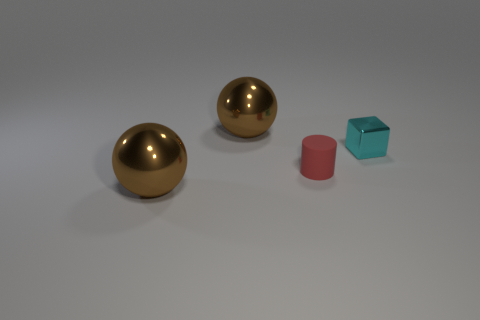Is there any other thing that has the same material as the small cylinder?
Offer a very short reply. No. There is a big metal thing that is behind the small shiny block; is its color the same as the rubber thing?
Offer a very short reply. No. What is the shape of the thing that is in front of the small cyan metal thing and left of the small matte object?
Provide a succinct answer. Sphere. What color is the thing in front of the tiny red rubber cylinder?
Your answer should be compact. Brown. Are there any other things that are the same color as the shiny cube?
Ensure brevity in your answer.  No. What number of spheres have the same material as the small cylinder?
Provide a succinct answer. 0. The matte thing is what color?
Ensure brevity in your answer.  Red. There is a thing that is behind the small cyan cube; does it have the same shape as the small red rubber thing?
Your answer should be very brief. No. How many objects are either big brown metal things that are behind the small cyan cube or tiny cubes?
Ensure brevity in your answer.  2. There is a cyan shiny thing that is the same size as the matte thing; what shape is it?
Ensure brevity in your answer.  Cube. 